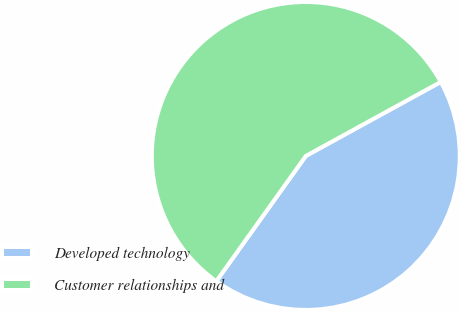Convert chart to OTSL. <chart><loc_0><loc_0><loc_500><loc_500><pie_chart><fcel>Developed technology<fcel>Customer relationships and<nl><fcel>42.86%<fcel>57.14%<nl></chart> 